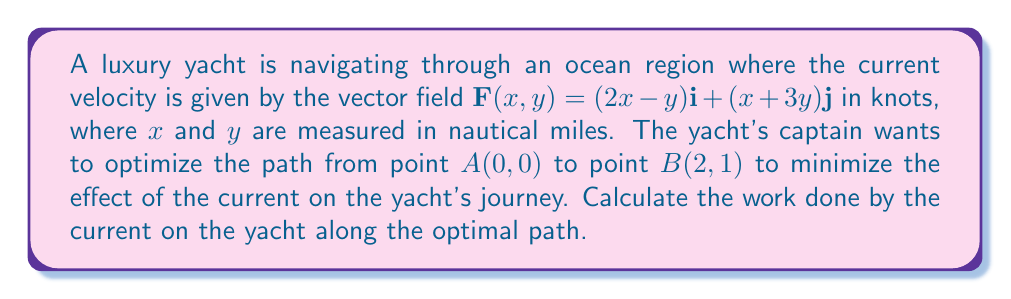Teach me how to tackle this problem. To solve this problem, we'll follow these steps:

1) The optimal path in a conservative vector field is always a straight line between two points. We need to check if $\mathbf{F}$ is conservative.

2) To check if $\mathbf{F}$ is conservative, we'll calculate $\frac{\partial P}{\partial y}$ and $\frac{\partial Q}{\partial x}$:

   $P = 2x-y$, so $\frac{\partial P}{\partial y} = -1$
   $Q = x+3y$, so $\frac{\partial Q}{\partial x} = 1$

   Since $\frac{\partial P}{\partial y} \neq \frac{\partial Q}{\partial x}$, $\mathbf{F}$ is not conservative.

3) However, the question asks for the optimal path, which is still the straight line between $A$ and $B$.

4) The parametric equations of the straight line from $A(0,0)$ to $B(2,1)$ are:
   $x(t) = 2t$, $y(t) = t$, where $0 \leq t \leq 1$

5) To calculate the work done, we need to integrate $\mathbf{F} \cdot d\mathbf{r}$ along this path:

   $W = \int_C \mathbf{F} \cdot d\mathbf{r} = \int_0^1 [(2x-y)\frac{dx}{dt} + (x+3y)\frac{dy}{dt}] dt$

6) Substituting the parametric equations and their derivatives:
   $\frac{dx}{dt} = 2$, $\frac{dy}{dt} = 1$

   $W = \int_0^1 [(2(2t)-t)(2) + (2t+3t)(1)] dt$

7) Simplifying:
   $W = \int_0^1 [4t-2t+2t+3t] dt = \int_0^1 7t dt$

8) Integrating:
   $W = [\frac{7t^2}{2}]_0^1 = \frac{7}{2} - 0 = \frac{7}{2}$

Therefore, the work done by the current on the yacht along the optimal path is $\frac{7}{2}$ knot-nautical miles.
Answer: $\frac{7}{2}$ knot-nautical miles 